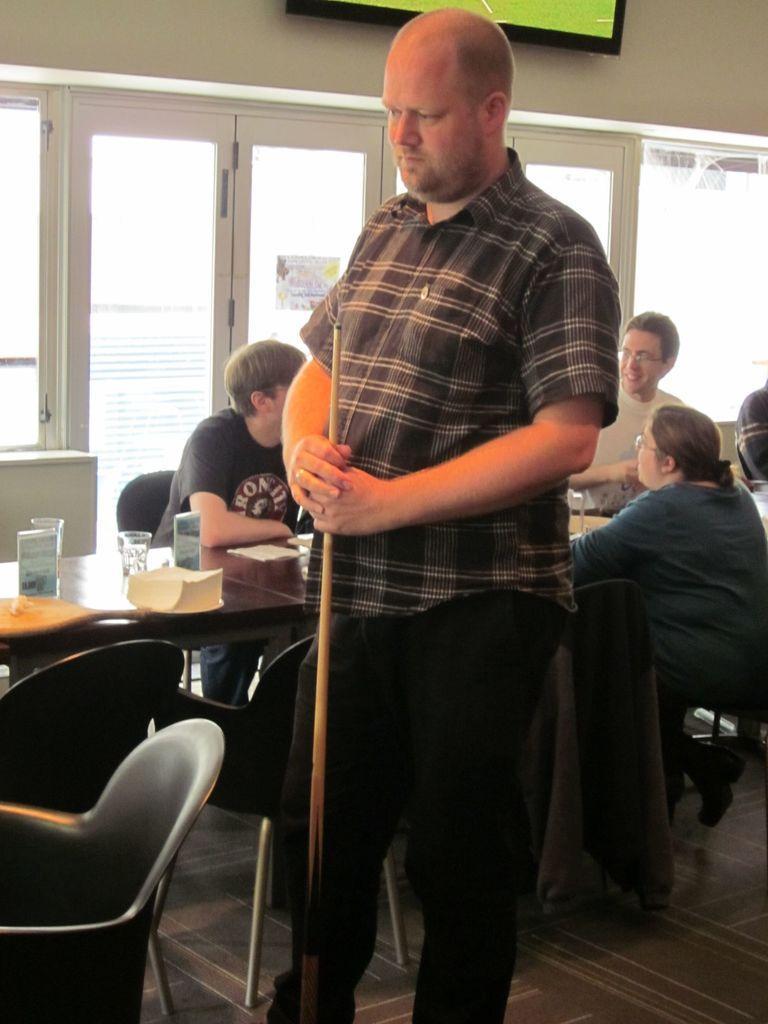Describe this image in one or two sentences. In the middle of the image a man is standing and holding a stick. Behind him there is a table on the table there are some glasses and papers. Surrounding the table there is a glass window. Top of the image there is a screen on the wall. Bottom left side of the image there are some chairs. 